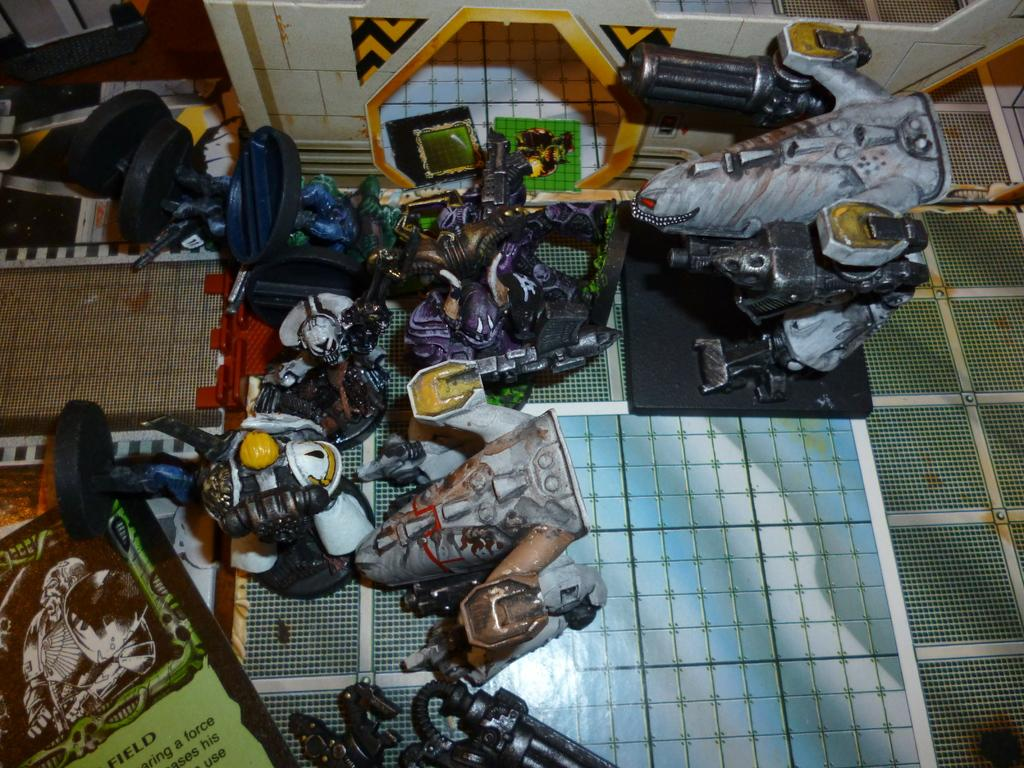What can be found on the floor in the image? There are toys on the floor in the image. What is on the wall in the image? There is a design on the wall in the image. What is hanging on the wall in the image? There is a banner with text and an image in the image. What type of ground can be seen in the image? There is no ground visible in the image; it appears to be an indoor setting. What kind of pan is being used to cook in the image? There is no pan or cooking activity present in the image. 